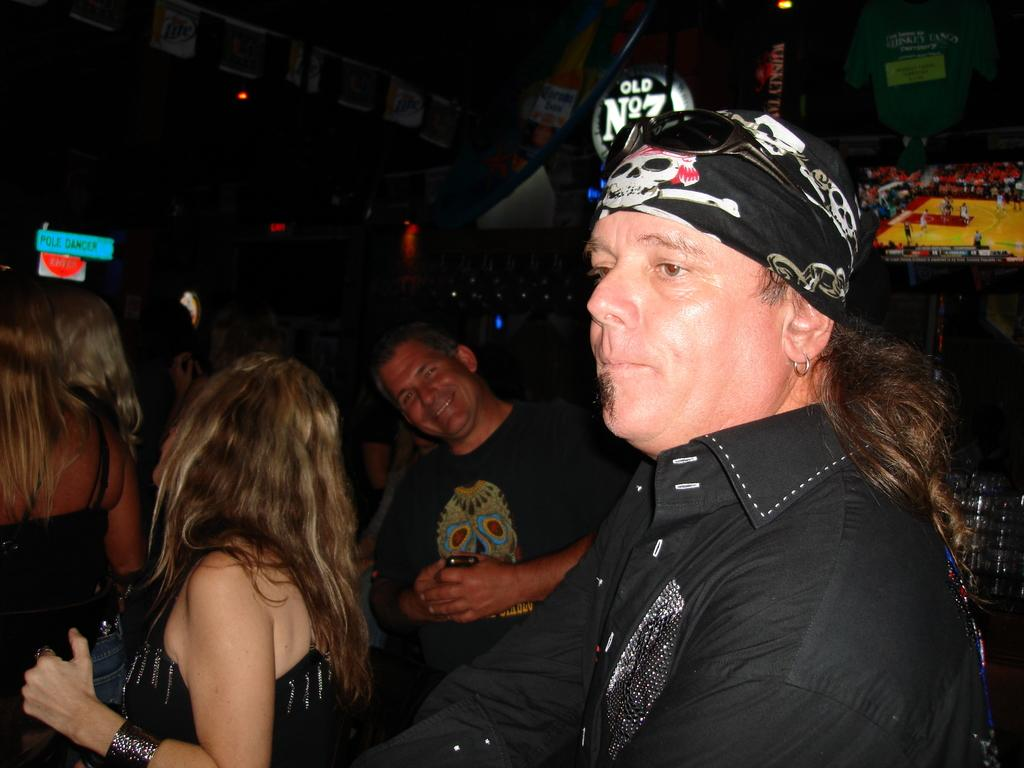How many people are in the image? There is a group of people in the image. What can be seen in the background of the image? There are banners, boards, and other objects in the background of the image. Where is the television located in the image? There is a television with a stand on the right side of the image. What type of jam is being served to the people in the image? There is no jam present in the image; it features a group of people, banners, boards, other objects, and a television. 